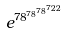Convert formula to latex. <formula><loc_0><loc_0><loc_500><loc_500>e ^ { 7 8 ^ { 7 8 ^ { 7 8 ^ { 7 2 2 } } } }</formula> 